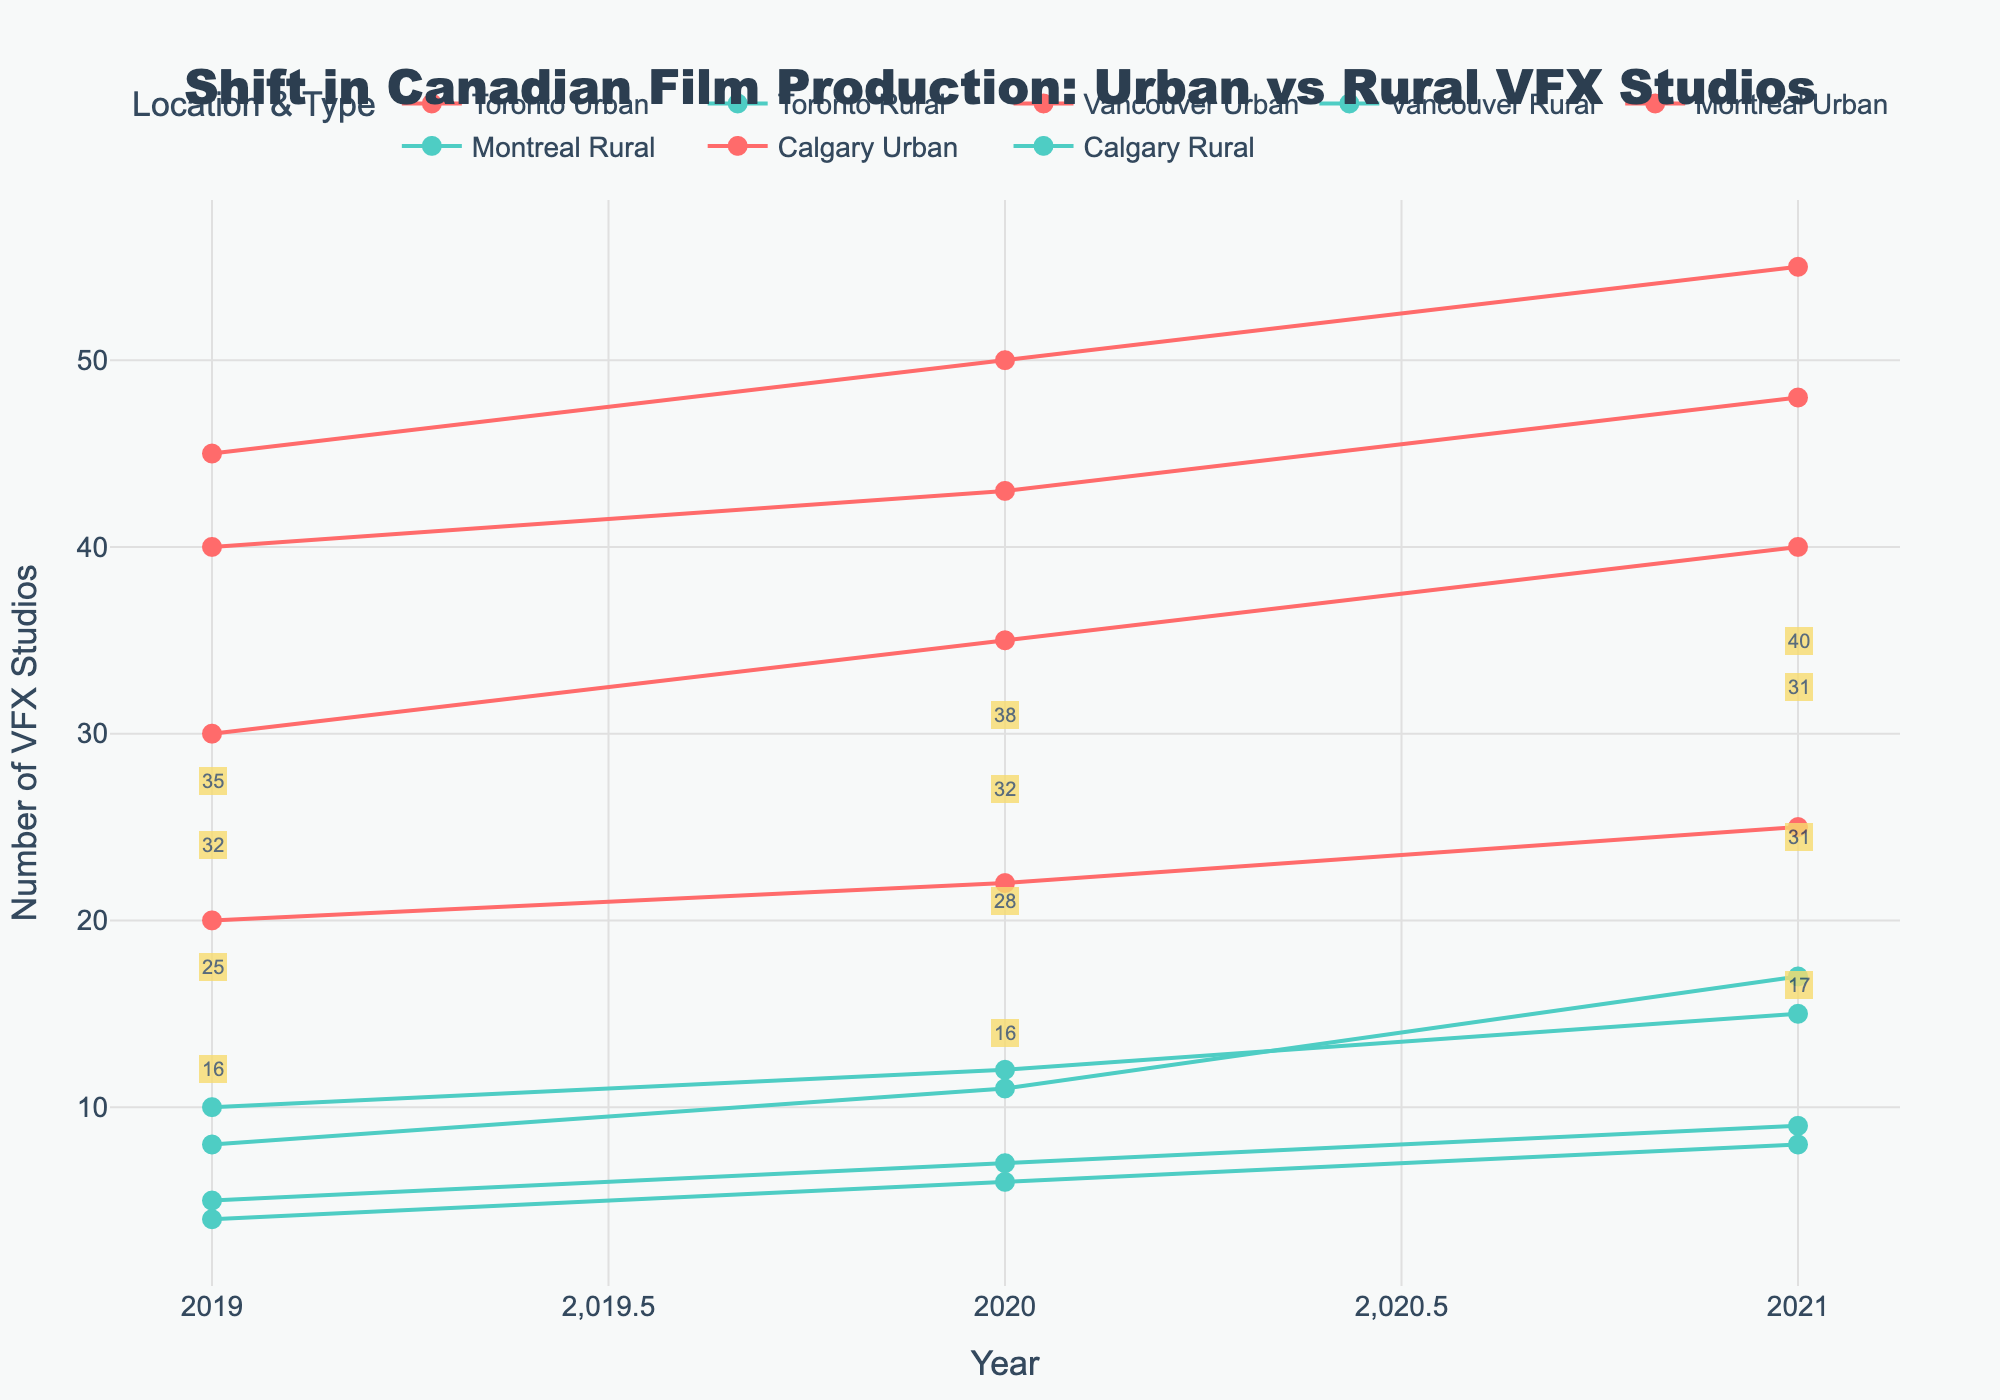What's the title of the plot? The title of the plot is typically found at the top of the figure. It serves as a summary of what the plot is about. By looking at the top of this plot, one can read the title.
Answer: Shift in Canadian Film Production: Urban vs Rural VFX Studios What do the x and y axes represent? The x-axis title is usually displayed along the horizontal axis and the y-axis title along the vertical axis. In this plot, the x-axis represents the year, and the y-axis represents the number of VFX studios.
Answer: The x-axis represents the year, and the y-axis represents the number of VFX studios How many data points are shown for each production location? Each production location has data points for three years: 2019, 2020, and 2021. So, each location has three data points.
Answer: 3 Which city had the highest difference between urban and rural VFX studios in 2021? Look for the annotations in 2021 and compare the differences for each city. Toronto had the most significant gap, with a difference of 40.
Answer: Toronto What's the overall trend in the number of VFX studios in urban areas from 2019 to 2021? Look at the lines representing urban studios (marked with red circles). All lines are increasing, indicating a growing trend.
Answer: Increasing For which location did the number of rural VFX studios grow the most from 2019 to 2021? Check each city's rural count in 2019 and 2021, and calculate the difference. Vancouver saw the biggest increase, going from 8 to 17.
Answer: Vancouver Compare the number of urban VFX studios in Toronto and Vancouver in 2020. Which one is higher? Look at the urban counts for Toronto and Vancouver in 2020. Toronto has 50, and Vancouver has 43, so Toronto is higher.
Answer: Toronto How does the number of rural VFX studios in Montreal in 2019 compare to Calgary in 2021? The rural count for Montreal in 2019 is 5, and for Calgary in 2021, it is 8. Calgary in 2021 has more.
Answer: Calgary in 2021 What is the difference in the number of urban VFX studios in Calgary between 2019 and 2021? Subtract the 2019 count from the 2021 count for urban VFX studios in Calgary: 25 - 20 = 5.
Answer: 5 Describe the pattern of annotations shown on the plot. The annotations are placed at the midpoint between the urban and rural data points each year and display the difference in counts between urban and rural VFX studios.
Answer: Midpoint annotations showing differences 